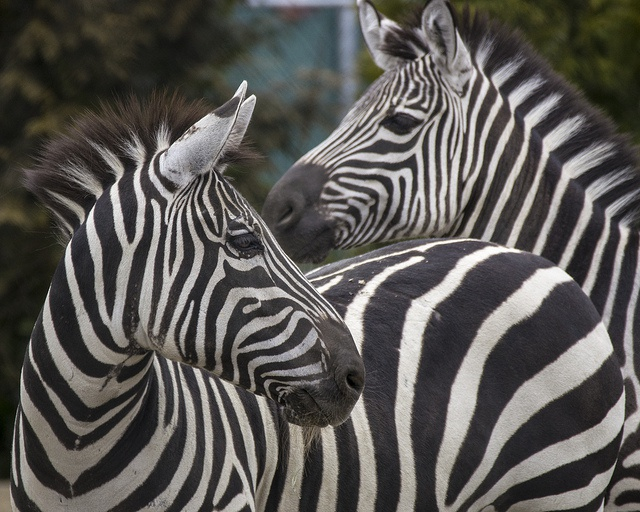Describe the objects in this image and their specific colors. I can see zebra in black, darkgray, gray, and lightgray tones and zebra in black, gray, darkgray, and lightgray tones in this image. 